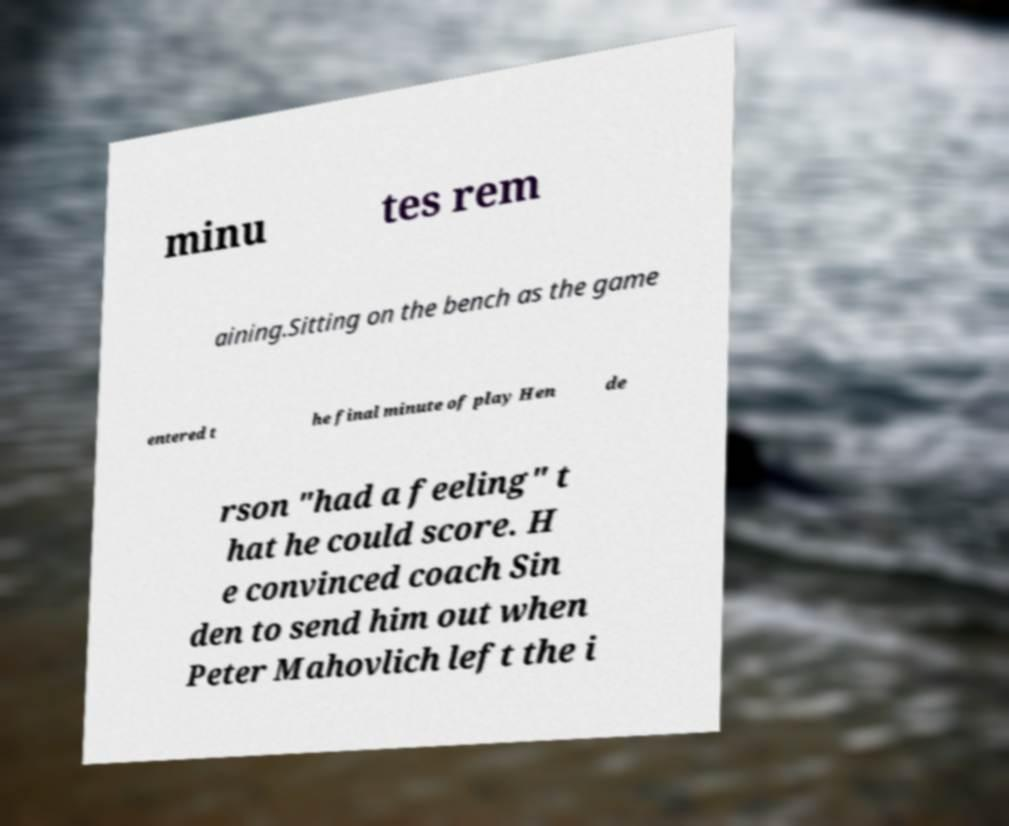Please identify and transcribe the text found in this image. minu tes rem aining.Sitting on the bench as the game entered t he final minute of play Hen de rson "had a feeling" t hat he could score. H e convinced coach Sin den to send him out when Peter Mahovlich left the i 